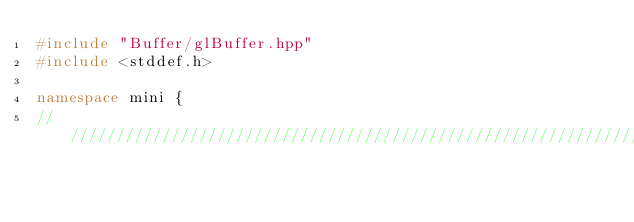Convert code to text. <code><loc_0><loc_0><loc_500><loc_500><_C++_>#include "Buffer/glBuffer.hpp"
#include <stddef.h>

namespace mini {
//////////////////////////////////////////////////////////////////////</code> 